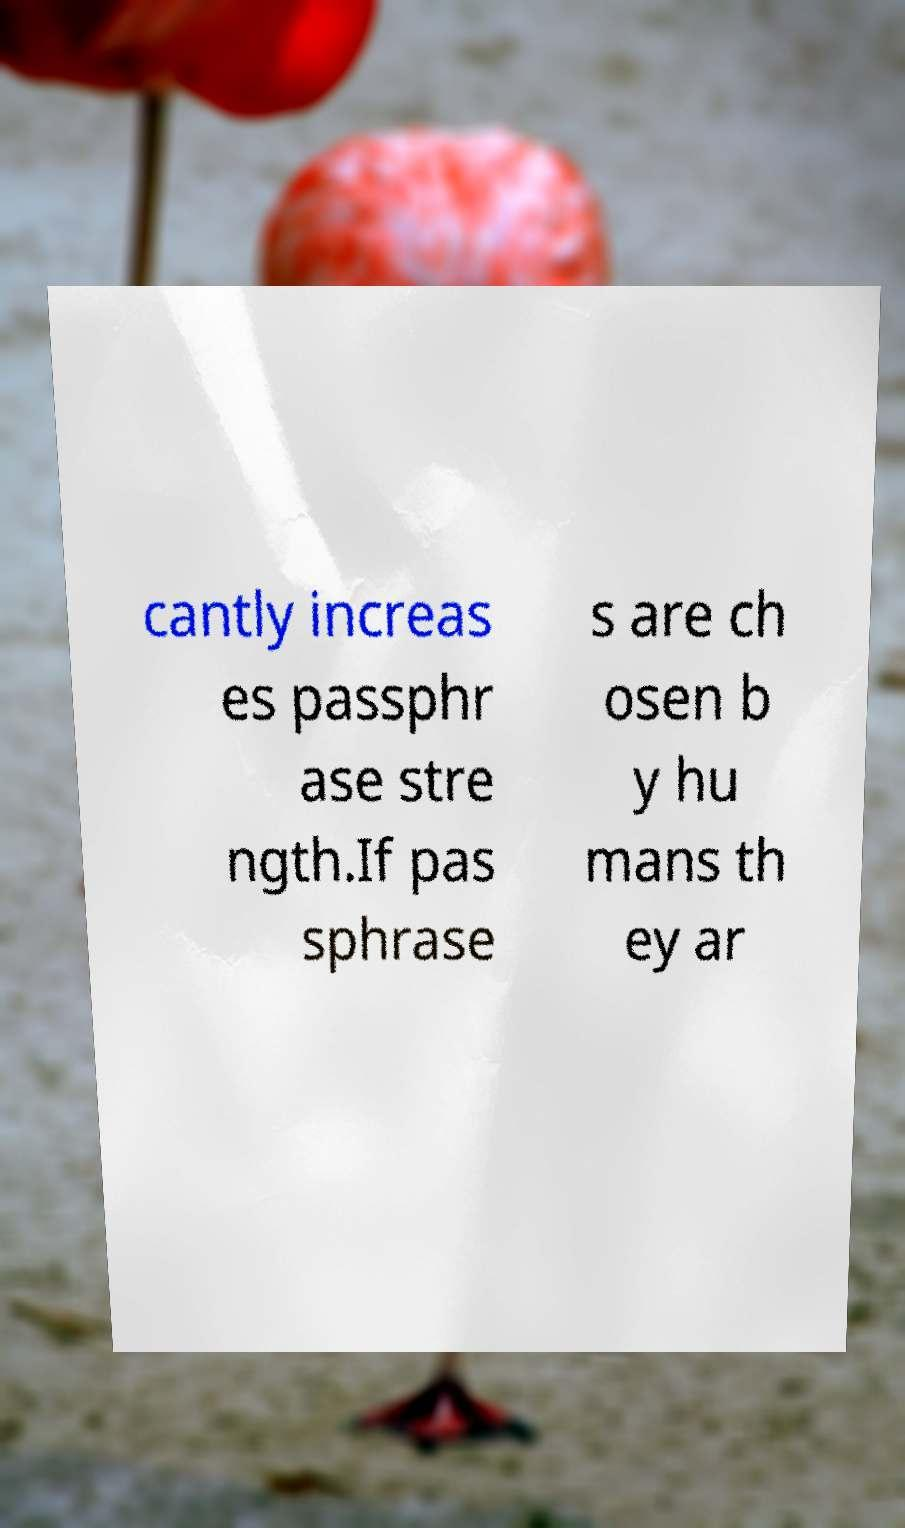I need the written content from this picture converted into text. Can you do that? cantly increas es passphr ase stre ngth.If pas sphrase s are ch osen b y hu mans th ey ar 